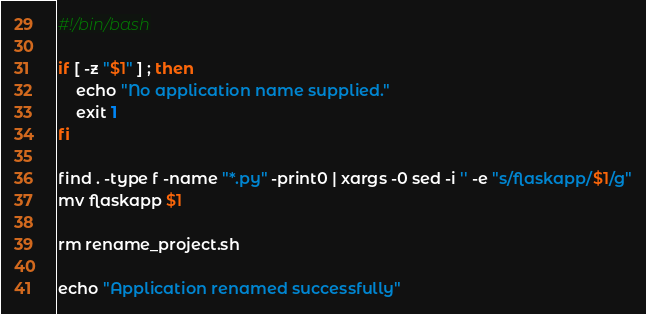Convert code to text. <code><loc_0><loc_0><loc_500><loc_500><_Bash_>#!/bin/bash

if [ -z "$1" ] ; then
    echo "No application name supplied."
    exit 1
fi

find . -type f -name "*.py" -print0 | xargs -0 sed -i '' -e "s/flaskapp/$1/g"
mv flaskapp $1

rm rename_project.sh

echo "Application renamed successfully"
</code> 